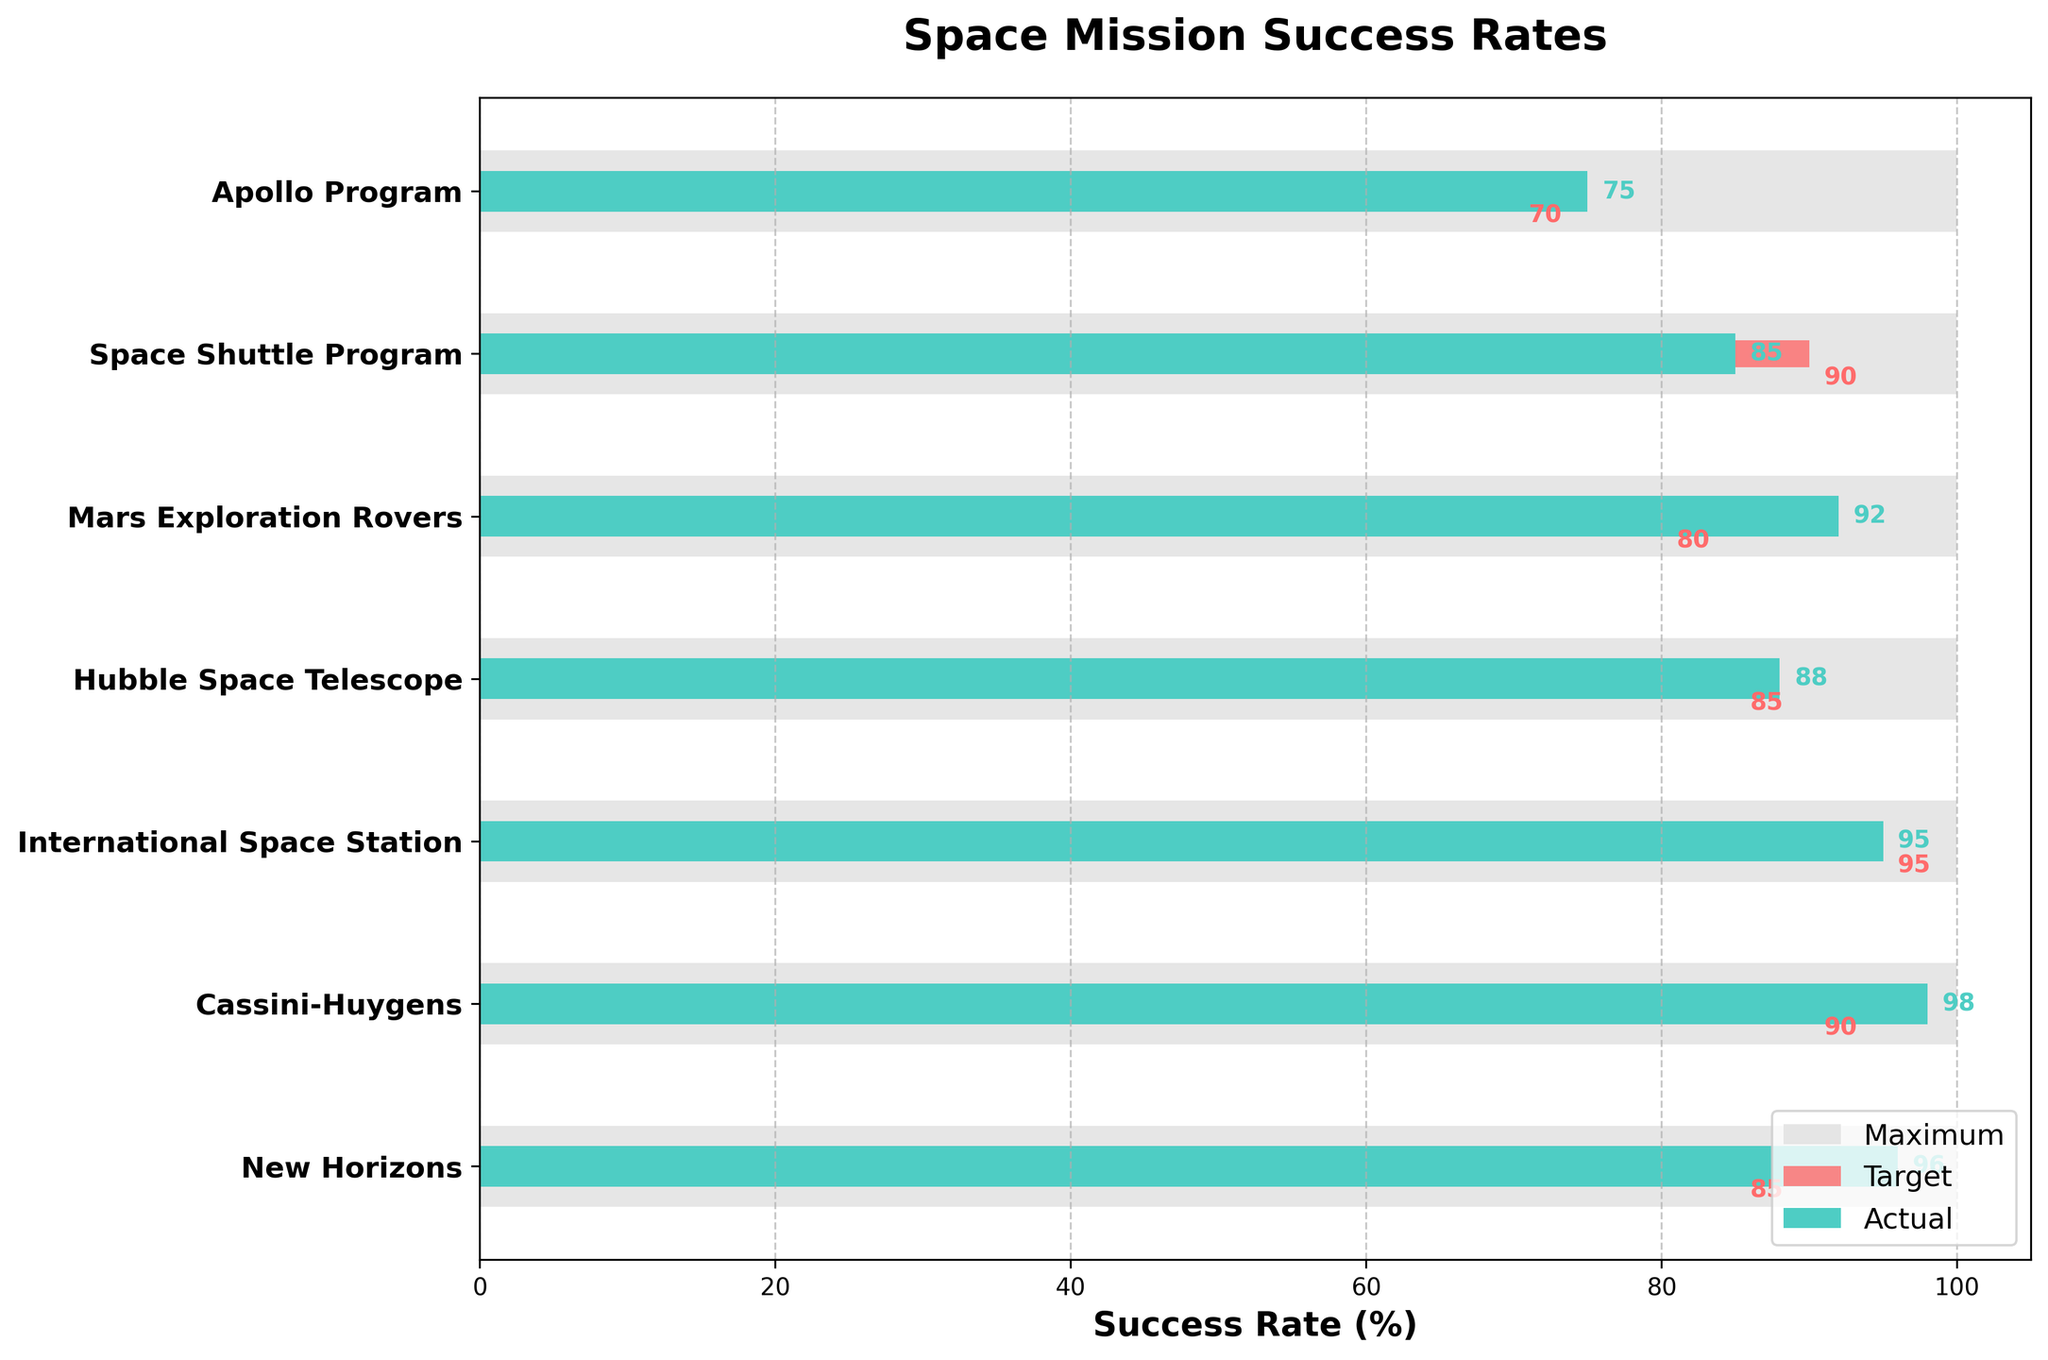How many missions are listed in the chart? Count the number of listed missions on the y-axis of the chart. There are seven missions: Apollo Program, Space Shuttle Program, Mars Exploration Rovers, Hubble Space Telescope, International Space Station, Cassini-Huygens, and New Horizons.
Answer: Seven Which mission has the highest actual success rate? Look at the bar lengths representing actual success rates. The longest bar goes to Cassini-Huygens, which has an actual success rate of 98%.
Answer: Cassini-Huygens What is the difference between the target and actual success rate of the Space Shuttle Program? Subtract the target rate of the Space Shuttle Program (90%) from the actual success rate (85%). The difference is 85 - 90 = -5.
Answer: -5 Which missions surpassed their target goal? Compare the lengths of the actual value bars to the target value bars. The missions that have longer actual value bars than their target value bars are: Mars Exploration Rovers, Hubble Space Telescope, Cassini-Huygens, and New Horizons.
Answer: Mars Exploration Rovers, Hubble Space Telescope, Cassini-Huygens, New Horizons Which mission has its actual success rate equal to its target rate? Identify if any mission's actual success rate bar equals the target rate bar length. The International Space Station has an actual and target rate of 95%.
Answer: International Space Station What is the median of the actual success rates? To find the median, list the actual success rates in ascending order: 75, 85, 88, 92, 95, 96, 98. The median is the middle value in this ordered list, which is 92.
Answer: 92 How many missions have an actual success rate greater than 90%? Count the number of missions with actual success rates above 90. These are Mars Exploration Rovers (92%), Hubble Space Telescope (88%), Cassini-Huygens (98%), and New Horizons (96%). There are 4 such missions.
Answer: 4 What is the sum of the target success rates for all missions? Add the target success rates: 70 (Apollo Program) + 90 (Space Shuttle Program) + 80 (Mars Exploration Rovers) + 85 (Hubble Space Telescope) + 95 (International Space Station) + 90 (Cassini-Huygens) + 85 (New Horizons). The total is 595.
Answer: 595 